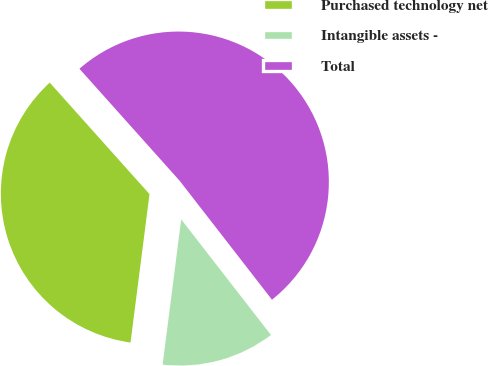Convert chart. <chart><loc_0><loc_0><loc_500><loc_500><pie_chart><fcel>Purchased technology net<fcel>Intangible assets -<fcel>Total<nl><fcel>36.36%<fcel>12.53%<fcel>51.11%<nl></chart> 